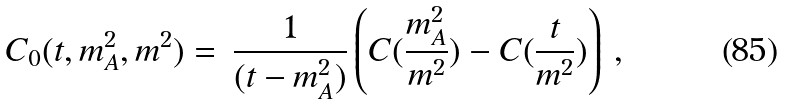<formula> <loc_0><loc_0><loc_500><loc_500>C _ { 0 } ( t , m _ { A } ^ { 2 } , m ^ { 2 } ) = \, \frac { 1 } { ( t - m _ { A } ^ { 2 } ) } \left ( C ( \frac { m _ { A } ^ { 2 } } { m ^ { 2 } } ) - C ( \frac { t } { m ^ { 2 } } ) \right ) \, ,</formula> 